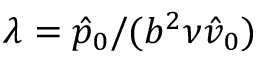<formula> <loc_0><loc_0><loc_500><loc_500>\lambda = \hat { p } _ { 0 } / ( b ^ { 2 } \nu \hat { v } _ { 0 } )</formula> 